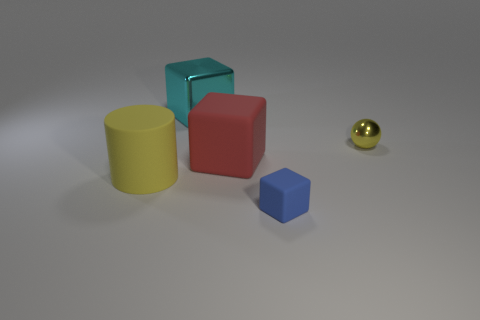Add 2 big cyan objects. How many objects exist? 7 Subtract all tiny blue matte blocks. How many blocks are left? 2 Subtract all blocks. How many objects are left? 2 Add 3 yellow rubber objects. How many yellow rubber objects are left? 4 Add 3 tiny metallic objects. How many tiny metallic objects exist? 4 Subtract 0 green cylinders. How many objects are left? 5 Subtract 2 cubes. How many cubes are left? 1 Subtract all cyan cylinders. Subtract all gray balls. How many cylinders are left? 1 Subtract all cyan spheres. How many red cubes are left? 1 Subtract all small blue rubber things. Subtract all blue things. How many objects are left? 3 